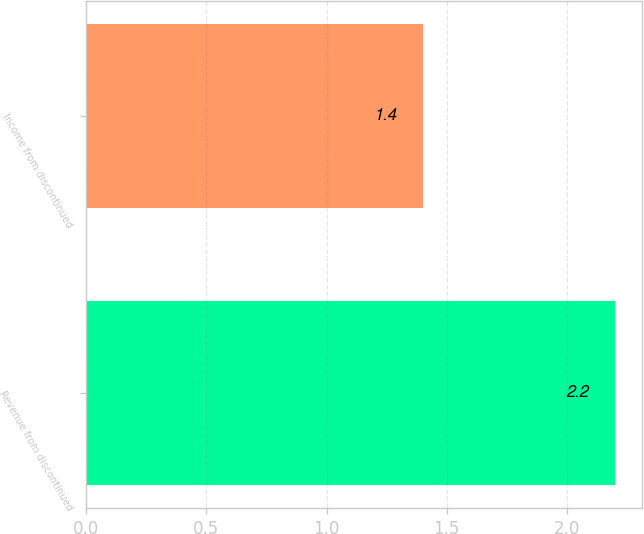Convert chart to OTSL. <chart><loc_0><loc_0><loc_500><loc_500><bar_chart><fcel>Revenue from discontinued<fcel>Income from discontinued<nl><fcel>2.2<fcel>1.4<nl></chart> 